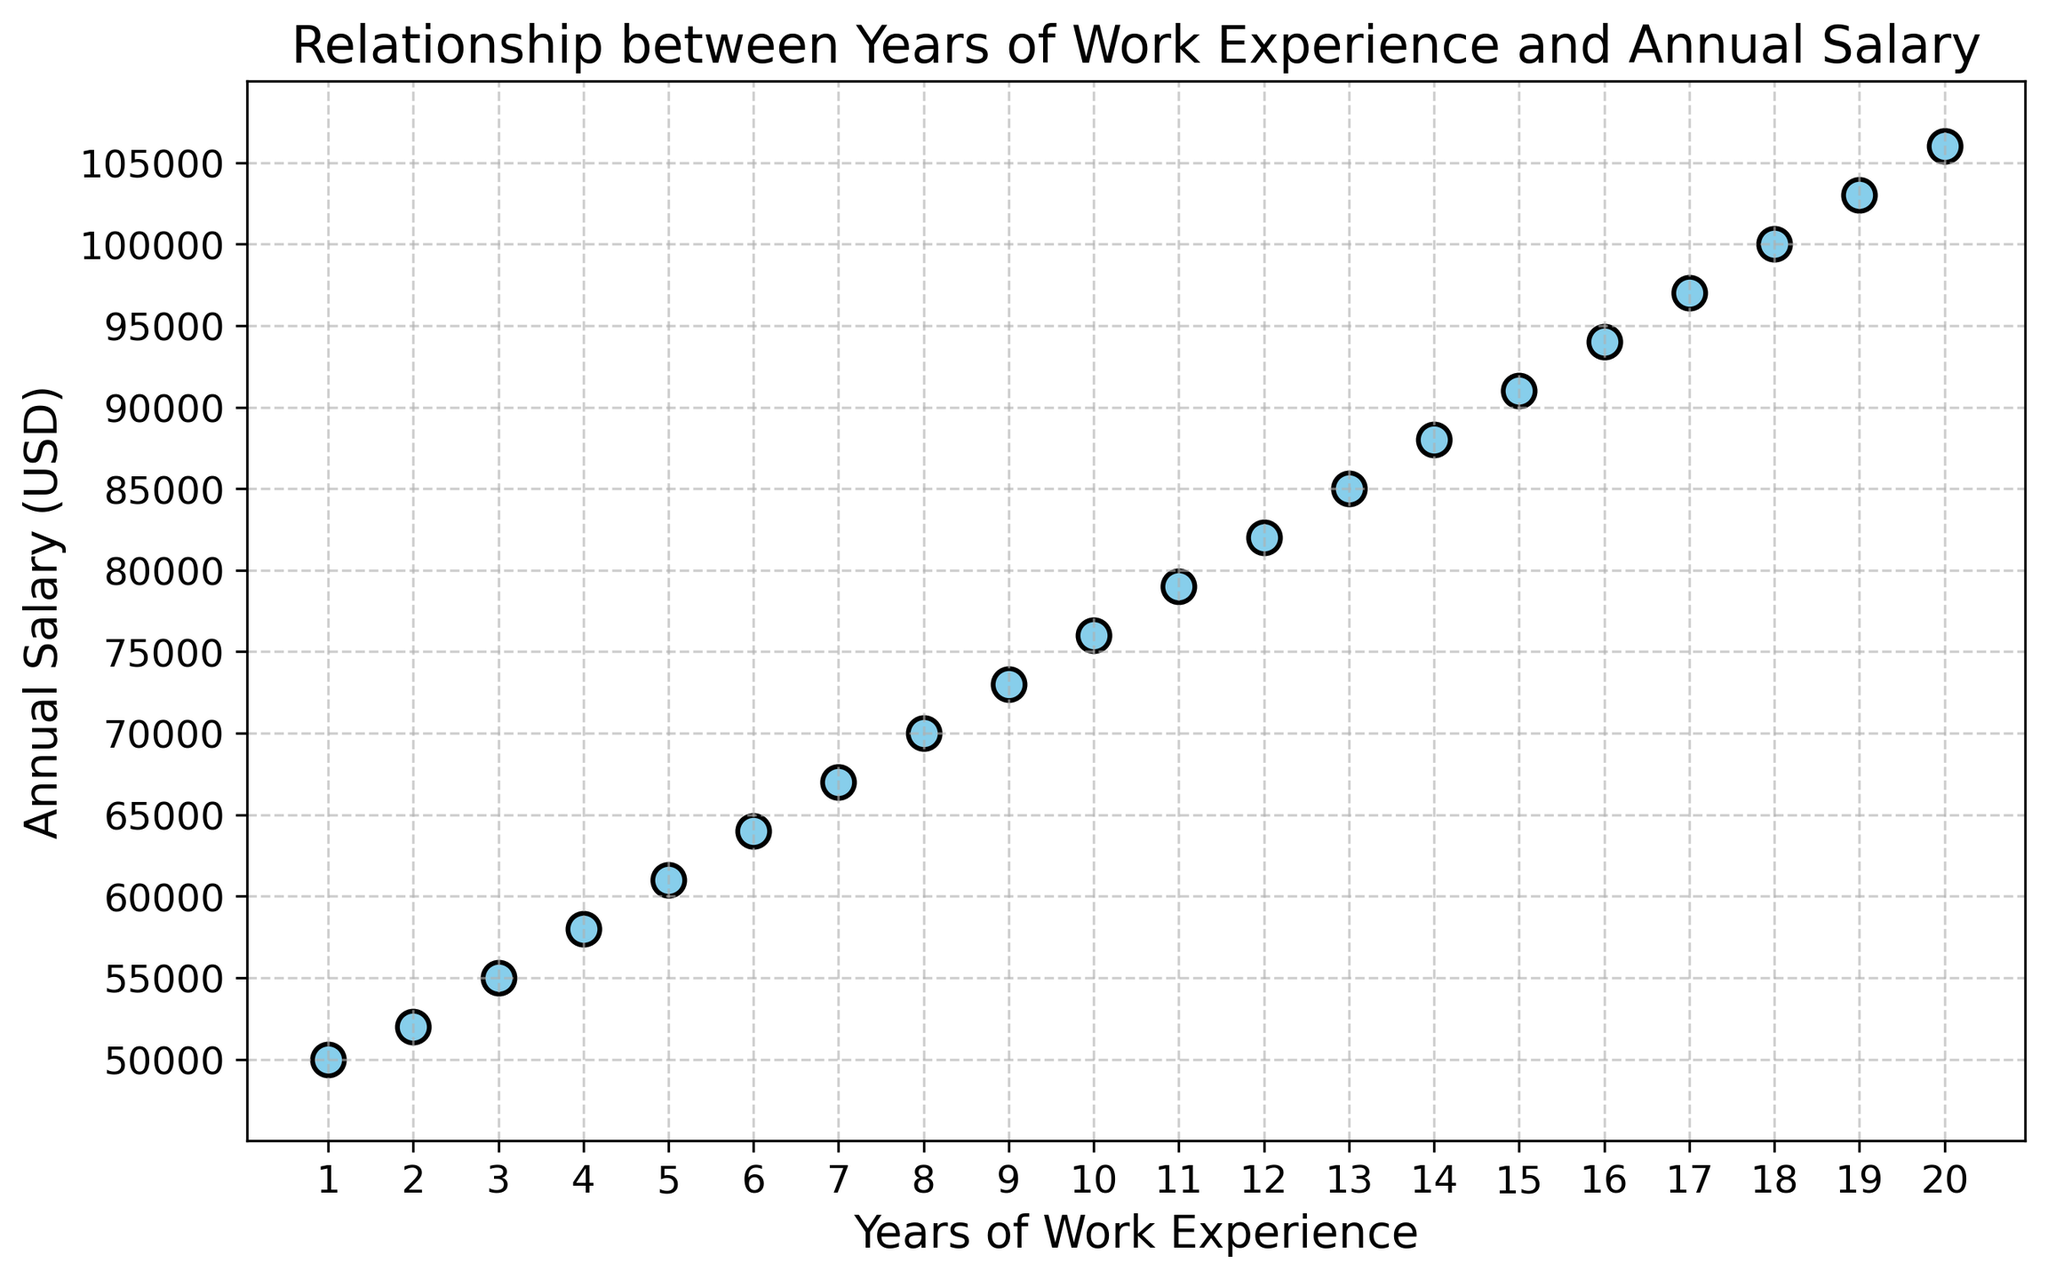What is the annual salary with 10 years of work experience? To find this, locate the point on the scatter plot where the x-axis is 10 and read the corresponding value on the y-axis. At 10 years of work experience, the annual salary is $76,000.
Answer: $76,000 How much does the annual salary increase from 5 years to 10 years of work experience? First, find the annual salary at 5 years, which is $61,000. Next, find the annual salary at 10 years, which is $76,000. The increase is $76,000 - $61,000 = $15,000.
Answer: $15,000 What is the average annual salary for someone with 1 to 5 years of work experience? Add the annual salaries for 1 through 5 years (50,000 + 52,000 + 55,000 + 58,000 + 61,000) which equals $276,000. Divide by the number of years, which is 5. So, $276,000 / 5 = $55,200.
Answer: $55,200 Which year shows the first salary of $100,000 or more? Locate the point on the scatter plot where the y-axis value is $100,000. Identify the corresponding x-axis value. The first instance is at 18 years of work experience.
Answer: 18 years By what percentage does the salary increase from 1 year to 5 years of work experience? The salary at 1 year is $50,000, and at 5 years, it's $61,000. Calculate the increase: $61,000 - $50,000 = $11,000. The percentage increase is ($11,000 / $50,000) * 100 = 22%.
Answer: 22% Is there a more significant salary increase between 2 to 8 years or 12 to 18 years of work experience? Calculate the increases for both periods. For 2 to 8 years: $70,000 - $52,000 = $18,000. For 12 to 18 years: $100,000 - $82,000 = $18,000. Both increases are $18,000.
Answer: Both are equal What is the median annual salary shown in the scatter plot? List all the annual salaries and find the middle value. With 20 data points, the median is the average of the 10th and 11th values. ($76,000 + $79,000) / 2 = $77,500.
Answer: $77,500 Is there a point where the annual salary plateaus, or does it increase consistently? Observe the trend of the plot visually. The annual salary consistently increases without any plateauing across the years of work experience.
Answer: Increases consistently Which years of work experience correspond to an annual salary of more than $90,000? Identify the points where the y-axis value is $90,000 or more. This occurs at 15 years and beyond.
Answer: 15 years and beyond 